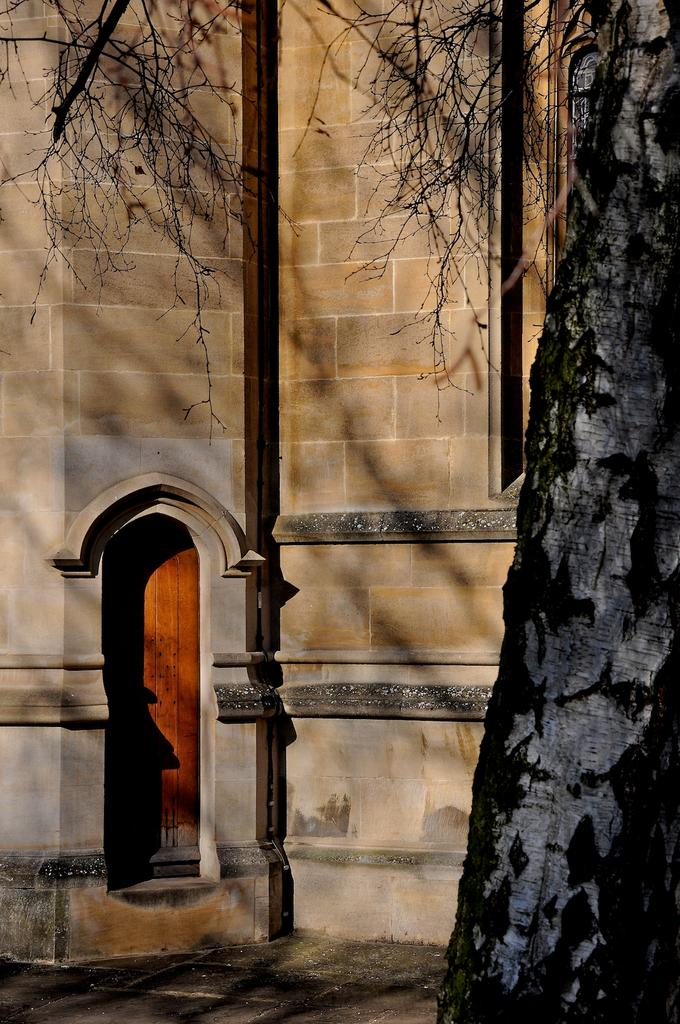What type of vegetation is on the right side of the image? There is a tree on the right side of the image. What can be seen in the background of the image? There is a building in the background of the image. What feature of a structure is visible in the image? There is a door visible in the image. Can you see any steam coming from the tree in the image? There is no steam present in the image. How many bananas are hanging from the tree in the image? There are no bananas visible in the image. 